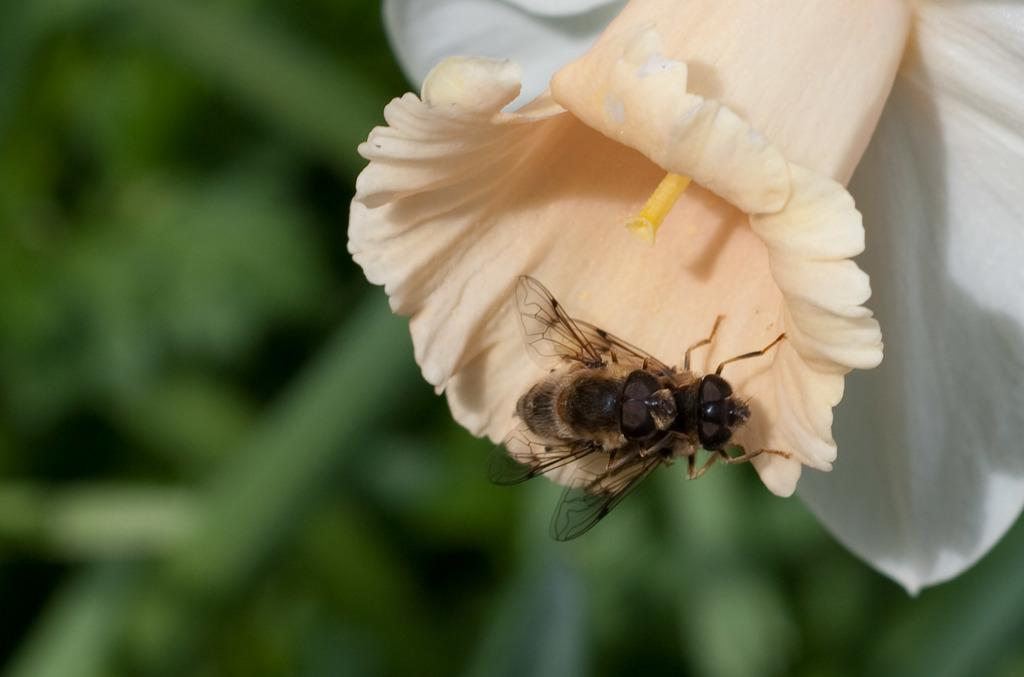What is the main subject in the middle of the picture? There is a flower in the middle of the picture. Is there anything else on the flower? Yes, there is an insect on the flower. Can you describe the background of the image? The background of the image is blurred. What type of guitar can be seen in the background of the image? There is no guitar present in the image; the background is blurred. How many dolls are sitting on the flower in the image? There are no dolls present in the image; it features a flower with an insect on it. 